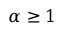Convert formula to latex. <formula><loc_0><loc_0><loc_500><loc_500>\alpha \geq 1</formula> 